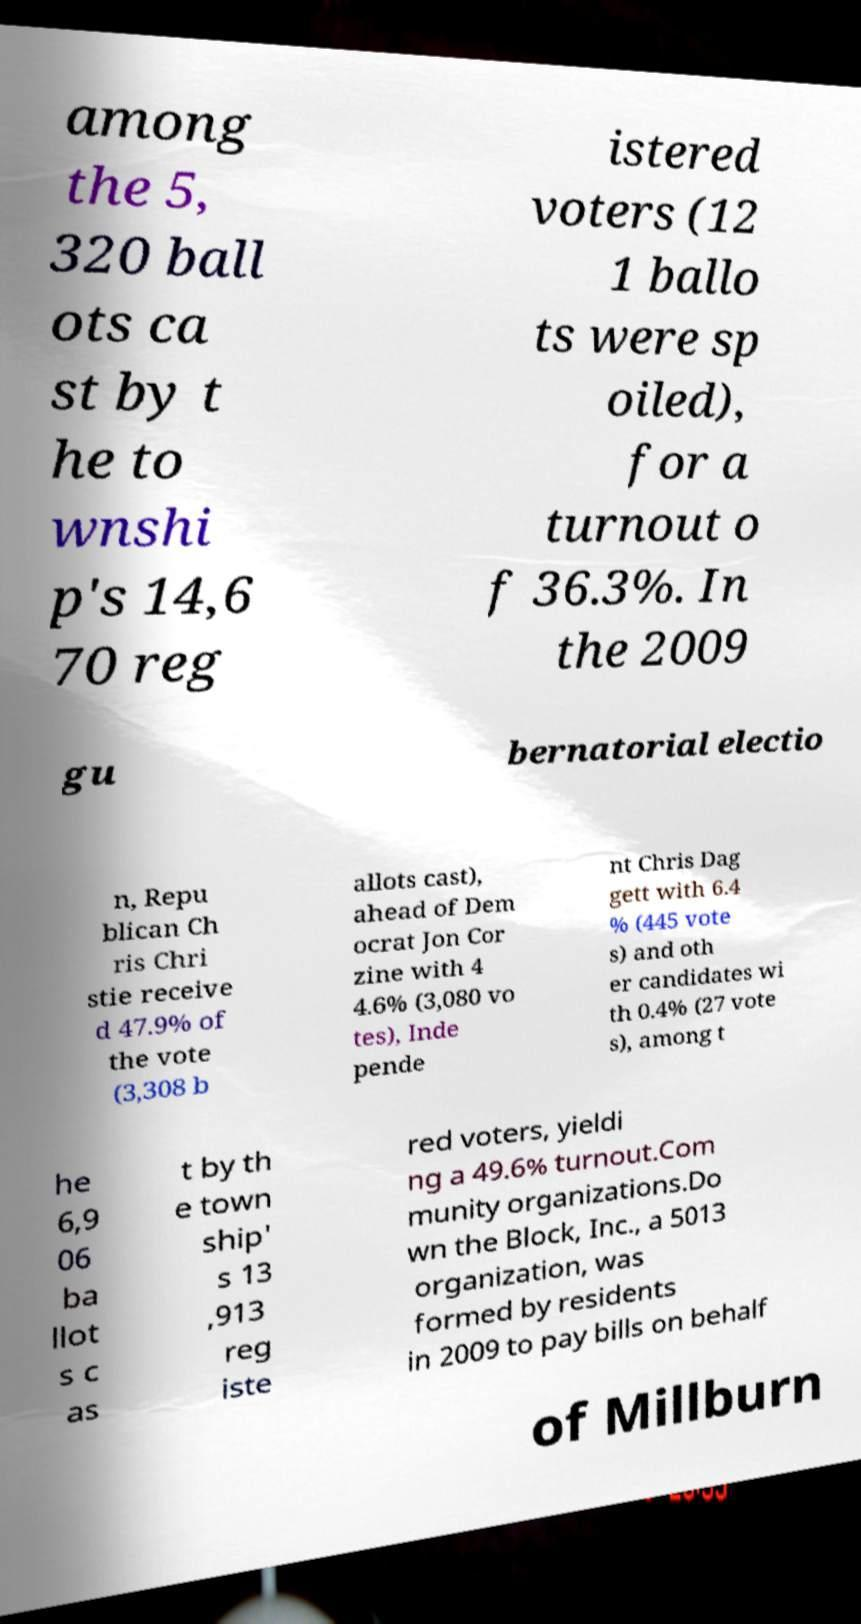There's text embedded in this image that I need extracted. Can you transcribe it verbatim? among the 5, 320 ball ots ca st by t he to wnshi p's 14,6 70 reg istered voters (12 1 ballo ts were sp oiled), for a turnout o f 36.3%. In the 2009 gu bernatorial electio n, Repu blican Ch ris Chri stie receive d 47.9% of the vote (3,308 b allots cast), ahead of Dem ocrat Jon Cor zine with 4 4.6% (3,080 vo tes), Inde pende nt Chris Dag gett with 6.4 % (445 vote s) and oth er candidates wi th 0.4% (27 vote s), among t he 6,9 06 ba llot s c as t by th e town ship' s 13 ,913 reg iste red voters, yieldi ng a 49.6% turnout.Com munity organizations.Do wn the Block, Inc., a 5013 organization, was formed by residents in 2009 to pay bills on behalf of Millburn 